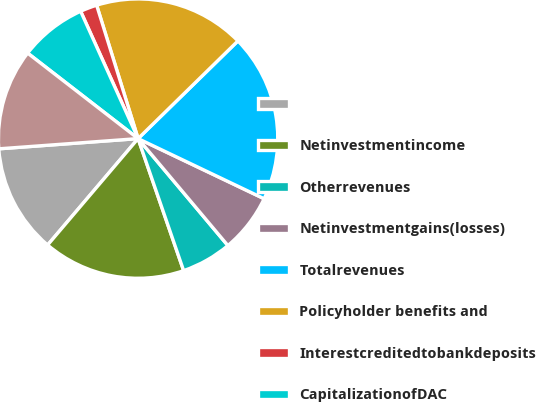<chart> <loc_0><loc_0><loc_500><loc_500><pie_chart><ecel><fcel>Netinvestmentincome<fcel>Otherrevenues<fcel>Netinvestmentgains(losses)<fcel>Totalrevenues<fcel>Policyholder benefits and<fcel>Interestcreditedtobankdeposits<fcel>CapitalizationofDAC<fcel>AmortizationofDACandVOBA<nl><fcel>12.62%<fcel>16.5%<fcel>5.83%<fcel>6.8%<fcel>19.41%<fcel>17.47%<fcel>1.95%<fcel>7.77%<fcel>11.65%<nl></chart> 